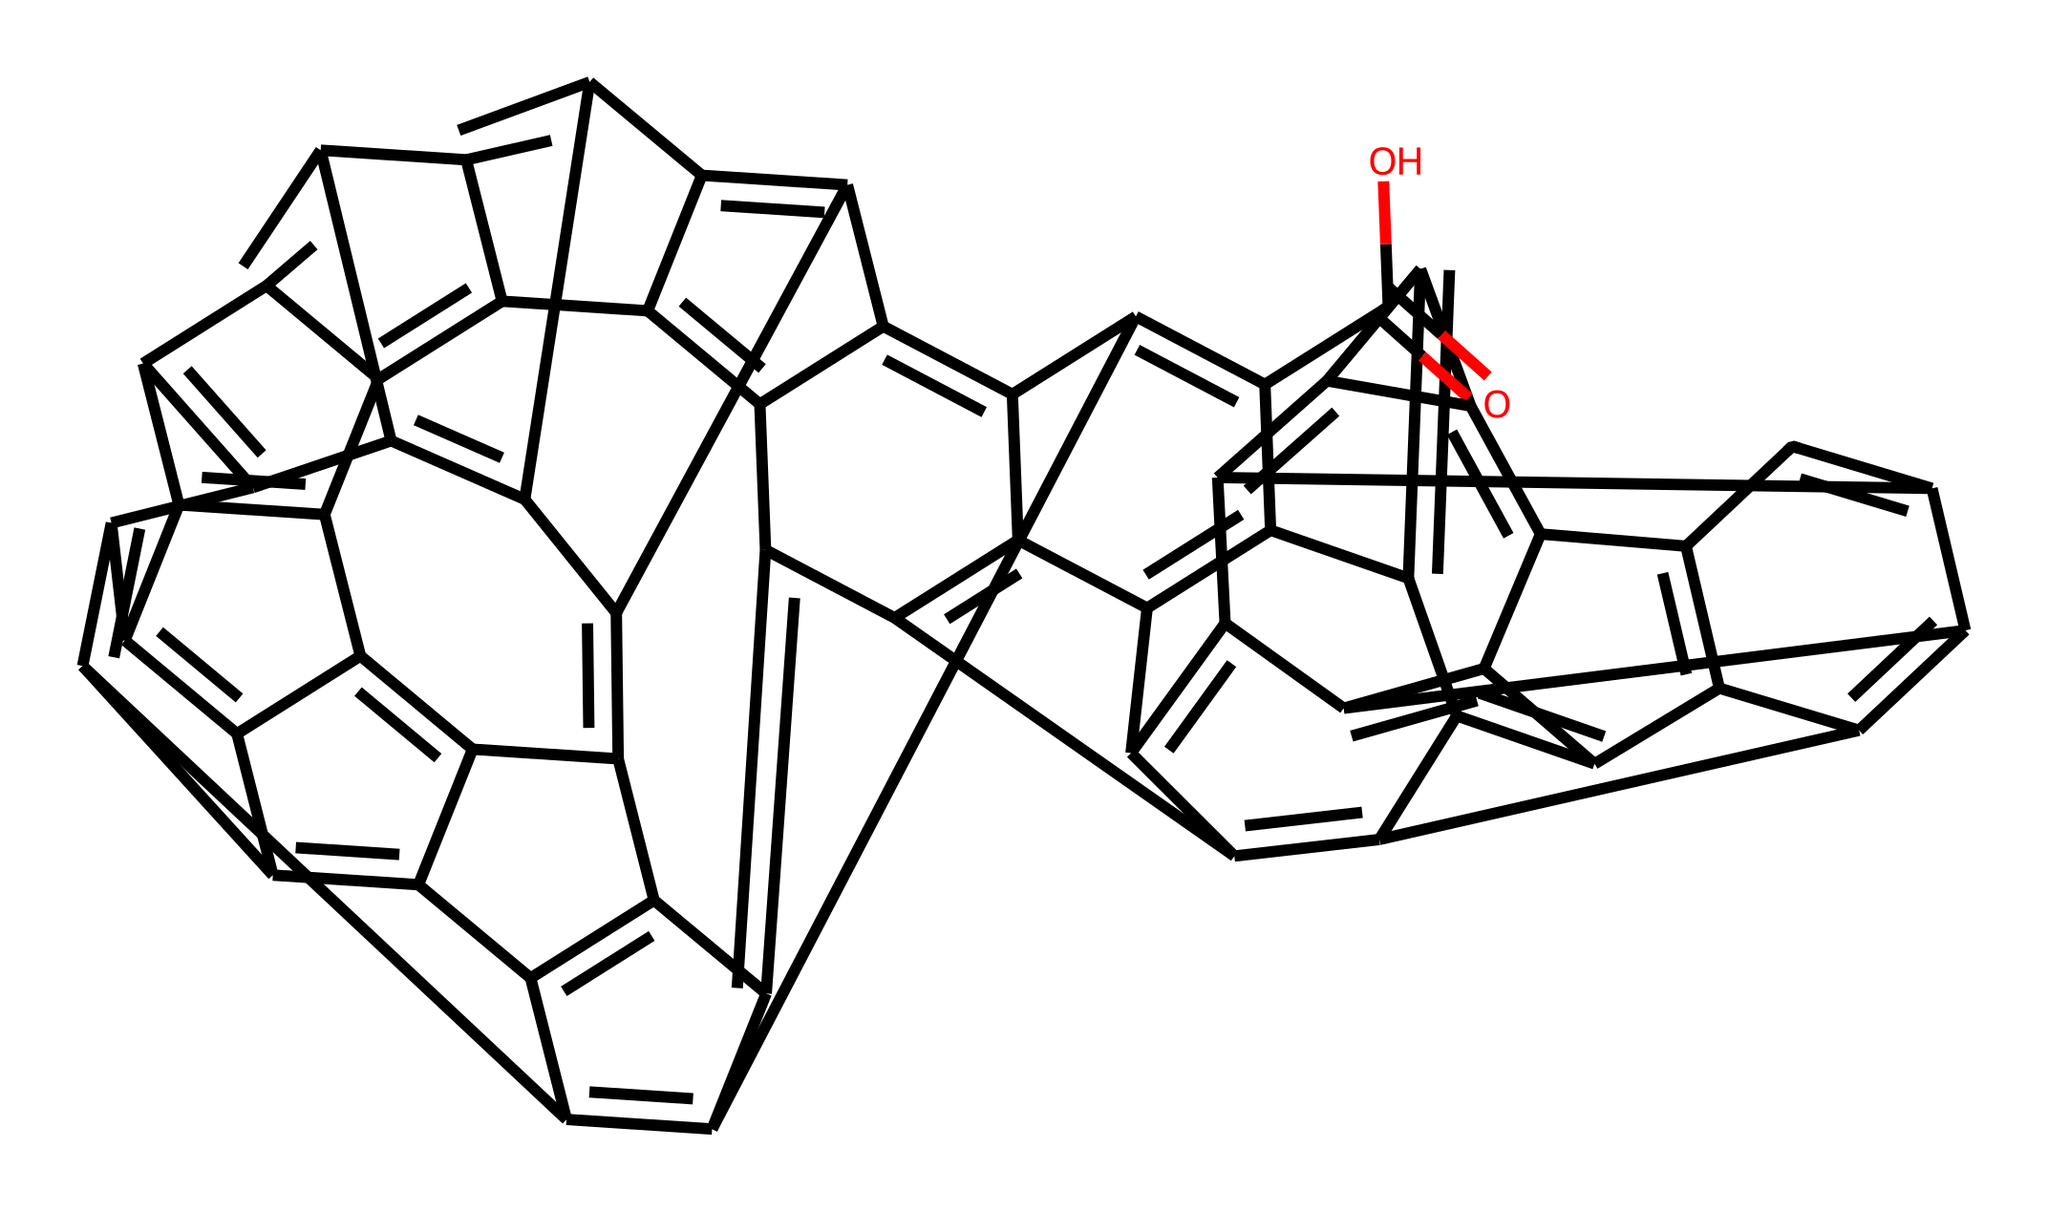What is the highest degree of unsaturation present in this molecule? The unsaturation degree can be assessed by counting the number of rings and pi bonds in the structure. Each ring or double bond contributes to unsaturation. The given SMILES depicts multiple rings and pi bonds, resulting in a high degree of unsaturation, typically calculated as one less than the number of carbons.
Answer: more than 20 How many carbon atoms are present in this fullerene derivative? To find the number of carbon atoms, count the "C" occurrences in the SMILES notation. Each "C" represents a carbon atom, and upon counting, you find there are a total of 60 carbon atoms in this structure.
Answer: 60 Which functional group is present in this fullerene derivative? By analyzing the end part of the SMILES string, the "C(=O)O" indicates the presence of a carboxylic acid functional group characterized by the carboxyl group (-COOH).
Answer: carboxylic acid What is the significance of the spherical structure of fullerenes in cosmetics? This spherical structure is significant because it can encapsulate and deliver antioxidants effectively, enhancing skin absorption. Furthermore, the unique geometry provides stability and allows for a better interaction with skin cells, which is beneficial in cosmetic formulations.
Answer: skin absorption What property of this compound contributes to its antioxidant capability? The presence of conjugated pi bonds due to the unsaturated connections within the carbon network allows the compound to effectively donate electrons and neutralize free radicals, a key property for antioxidant activity.
Answer: electron donation 